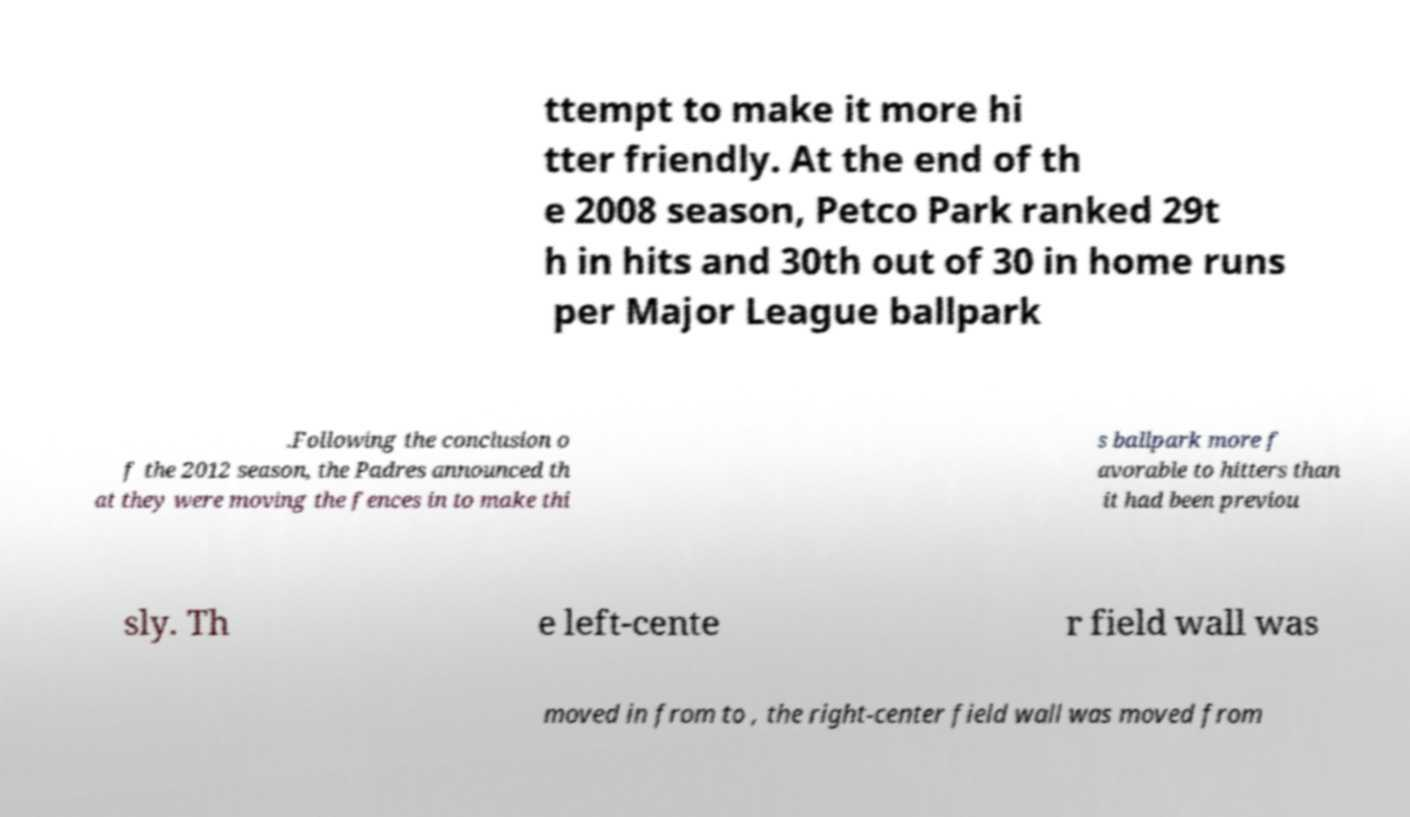I need the written content from this picture converted into text. Can you do that? ttempt to make it more hi tter friendly. At the end of th e 2008 season, Petco Park ranked 29t h in hits and 30th out of 30 in home runs per Major League ballpark .Following the conclusion o f the 2012 season, the Padres announced th at they were moving the fences in to make thi s ballpark more f avorable to hitters than it had been previou sly. Th e left-cente r field wall was moved in from to , the right-center field wall was moved from 